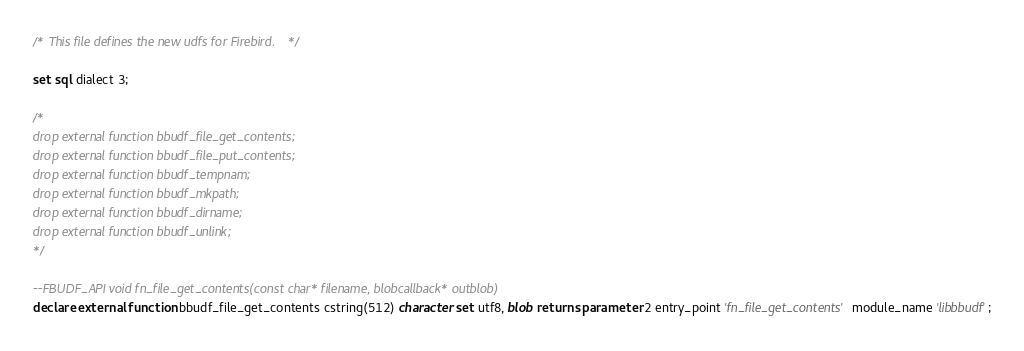<code> <loc_0><loc_0><loc_500><loc_500><_SQL_>/* This file defines the new udfs for Firebird. */

set sql dialect 3;

/*
drop external function bbudf_file_get_contents;
drop external function bbudf_file_put_contents;
drop external function bbudf_tempnam;
drop external function bbudf_mkpath;
drop external function bbudf_dirname;
drop external function bbudf_unlink;
*/

--FBUDF_API void fn_file_get_contents(const char* filename, blobcallback* outblob)
declare external function bbudf_file_get_contents cstring(512) character set utf8, blob returns parameter 2 entry_point 'fn_file_get_contents' module_name 'libbbudf';</code> 